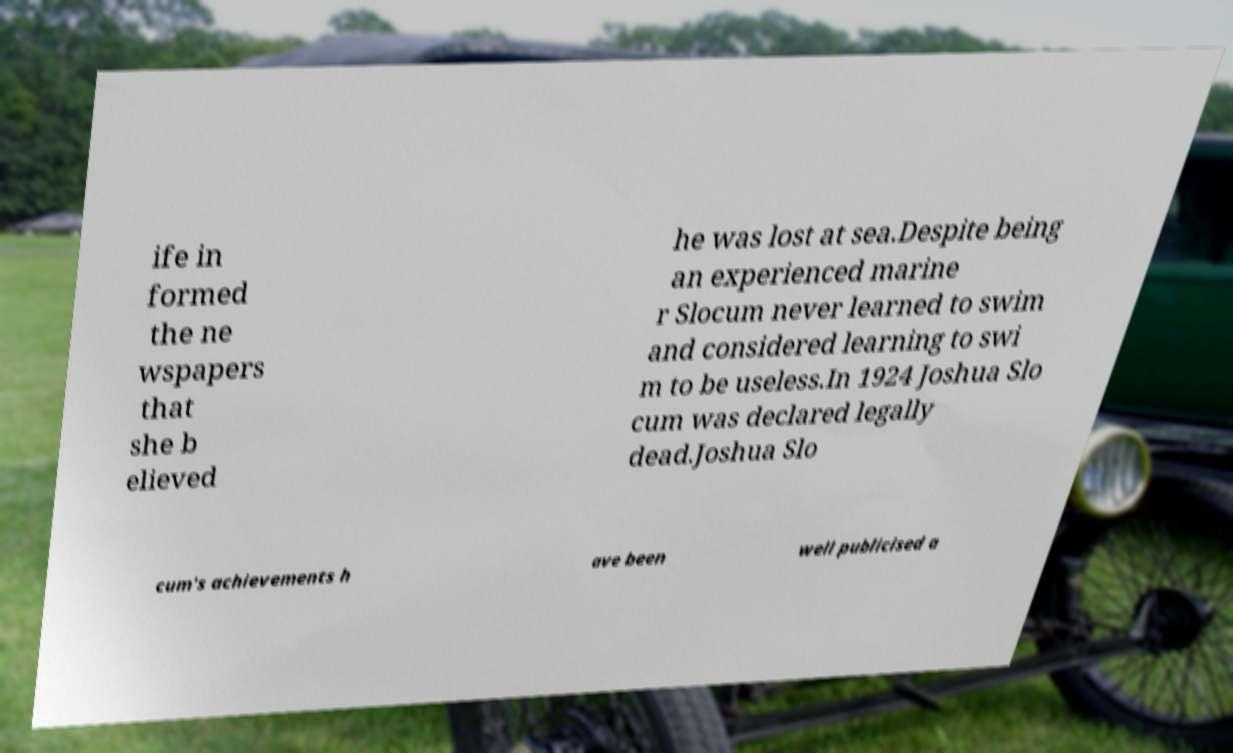For documentation purposes, I need the text within this image transcribed. Could you provide that? ife in formed the ne wspapers that she b elieved he was lost at sea.Despite being an experienced marine r Slocum never learned to swim and considered learning to swi m to be useless.In 1924 Joshua Slo cum was declared legally dead.Joshua Slo cum's achievements h ave been well publicised a 